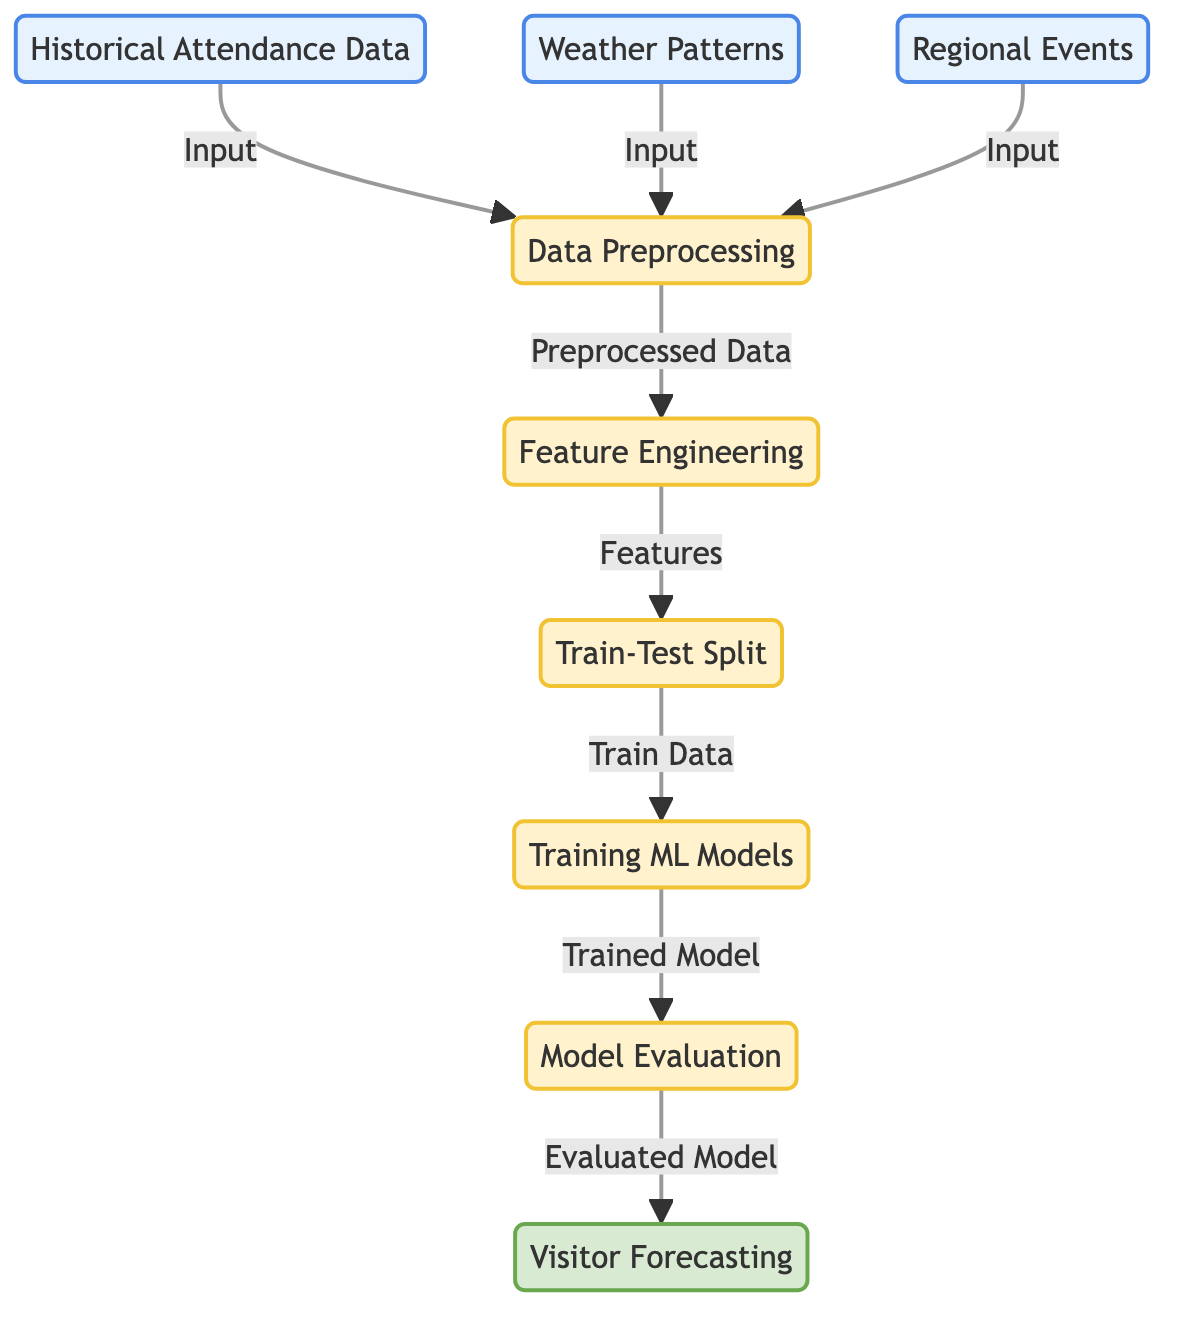What are the three main inputs in this diagram? The inputs listed in the diagram are historical attendance data, weather patterns, and regional events. These are shown as three separate nodes leading into the data preprocessing node.
Answer: Historical Attendance Data, Weather Patterns, Regional Events What is the first process after inputs are provided? After the inputs are provided, the first process indicated in the diagram is data preprocessing. This node receives inputs from the three prior input nodes.
Answer: Data Preprocessing How many main process nodes are shown in the diagram? The diagram contains five main process nodes: data preprocessing, feature engineering, train-test split, training ML models, and model evaluation.
Answer: Five What type of output does the diagram indicate is produced at the end? The final output produced according to the diagram is visitor forecasting. This is shown as the last node in the flow.
Answer: Visitor Forecasting What step follows feature engineering in the machine learning process shown? Following feature engineering in the diagram is the train-test split process. This indicates that the features derived need to be divided into training and testing data.
Answer: Train-Test Split Which node evaluates the model before forecasting visitors? The model evaluation node assesses the trained model's performance before visitor forecasting occurs, according to the flow of the diagram.
Answer: Model Evaluation What is the purpose of the data preprocessing step? The purpose of the data preprocessing step is to prepare the input data from historical attendance, weather, and regional events for further analysis in the feature engineering stage.
Answer: Prepare data How is the train-test split step represented in the diagram? The train-test split is represented as a process node where the data is divided into training and testing sets, facilitating the subsequent training of the ML models.
Answer: Process Node In which step do historical attendance data, weather patterns, and regional events come together? These three data types come together in the data preprocessing step, where they are combined for further analysis before feature engineering.
Answer: Data Preprocessing 